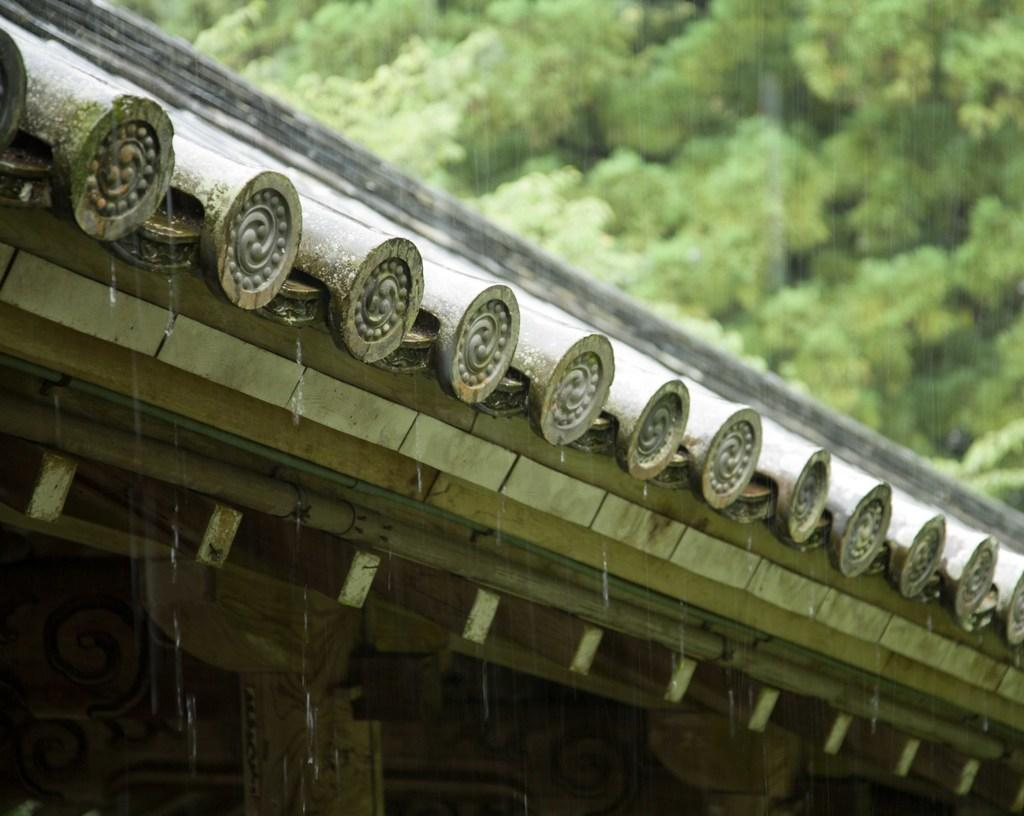What part of a building is shown in the image? The image shows the roof of a building. What can be seen on the roof in the image? Water lines are visible on the roof. Are there any natural elements visible in the image? Yes, there are trees visible in the top right corner of the image. What type of pail is being used to teach the pests in the image? There is no pail or pests present in the image, so this question cannot be answered. 